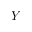Convert formula to latex. <formula><loc_0><loc_0><loc_500><loc_500>Y</formula> 